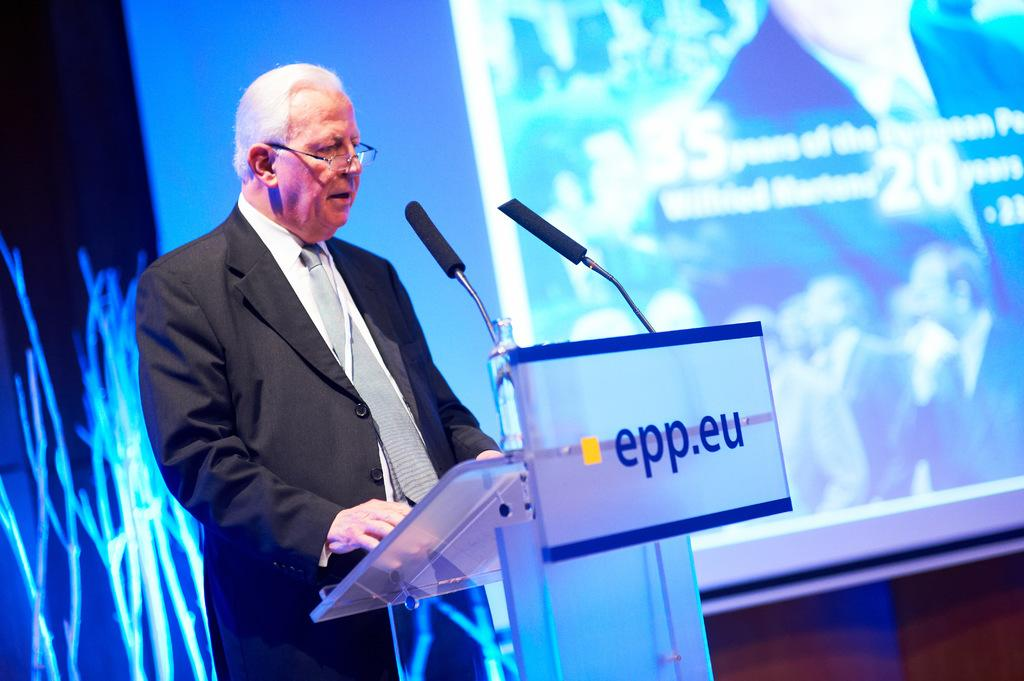Who or what is in the image? There is a person in the image. What is in front of the person? There is a podium in front of the person. What is near the podium? There are microphones near the podium. What can be seen in the background? There is a projector screen and other objects visible in the background. What type of trail can be seen behind the person in the image? There is no trail visible in the image; it is an indoor setting with a podium, microphones, projector screen, and other objects in the background. 